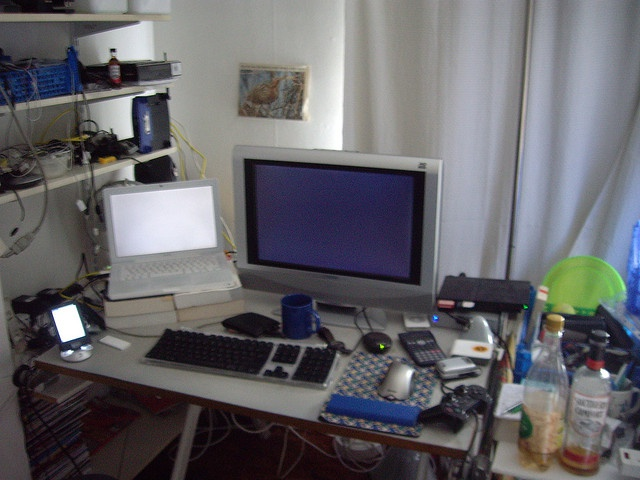Describe the objects in this image and their specific colors. I can see tv in black, navy, gray, and darkgray tones, laptop in black, gray, lavender, and darkgray tones, keyboard in black and gray tones, bottle in black, gray, and darkgray tones, and bottle in black, gray, and maroon tones in this image. 